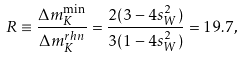Convert formula to latex. <formula><loc_0><loc_0><loc_500><loc_500>R \equiv \frac { \Delta m _ { K } ^ { \min } } { \Delta m _ { K } ^ { r h n } } = \frac { 2 ( 3 - 4 s _ { W } ^ { 2 } ) } { 3 ( 1 - 4 s _ { W } ^ { 2 } ) } = 1 9 . 7 ,</formula> 